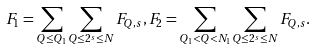<formula> <loc_0><loc_0><loc_500><loc_500>F _ { 1 } = \sum _ { Q \leq Q _ { 1 } } \sum _ { Q \leq 2 ^ { s } \leq N } F _ { Q , s } , F _ { 2 } = \sum _ { Q _ { 1 } < Q < N _ { 1 } } \sum _ { Q \leq 2 ^ { s } \leq N } F _ { Q , s } .</formula> 